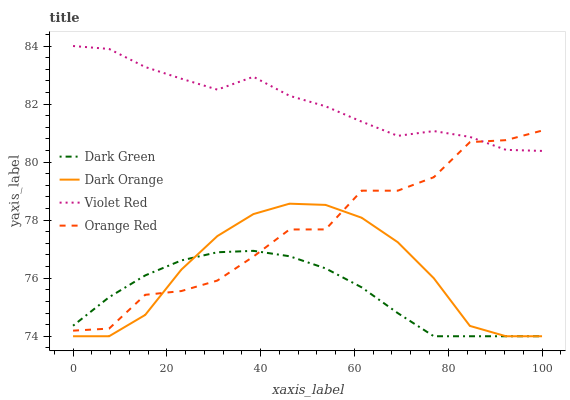Does Dark Green have the minimum area under the curve?
Answer yes or no. Yes. Does Violet Red have the maximum area under the curve?
Answer yes or no. Yes. Does Orange Red have the minimum area under the curve?
Answer yes or no. No. Does Orange Red have the maximum area under the curve?
Answer yes or no. No. Is Dark Green the smoothest?
Answer yes or no. Yes. Is Orange Red the roughest?
Answer yes or no. Yes. Is Violet Red the smoothest?
Answer yes or no. No. Is Violet Red the roughest?
Answer yes or no. No. Does Dark Orange have the lowest value?
Answer yes or no. Yes. Does Orange Red have the lowest value?
Answer yes or no. No. Does Violet Red have the highest value?
Answer yes or no. Yes. Does Orange Red have the highest value?
Answer yes or no. No. Is Dark Green less than Violet Red?
Answer yes or no. Yes. Is Violet Red greater than Dark Orange?
Answer yes or no. Yes. Does Violet Red intersect Orange Red?
Answer yes or no. Yes. Is Violet Red less than Orange Red?
Answer yes or no. No. Is Violet Red greater than Orange Red?
Answer yes or no. No. Does Dark Green intersect Violet Red?
Answer yes or no. No. 